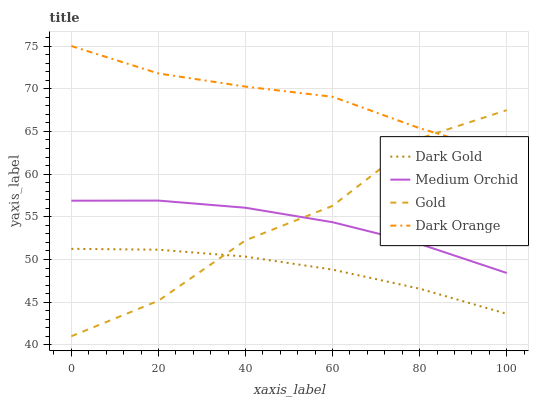Does Dark Gold have the minimum area under the curve?
Answer yes or no. Yes. Does Dark Orange have the maximum area under the curve?
Answer yes or no. Yes. Does Medium Orchid have the minimum area under the curve?
Answer yes or no. No. Does Medium Orchid have the maximum area under the curve?
Answer yes or no. No. Is Dark Gold the smoothest?
Answer yes or no. Yes. Is Gold the roughest?
Answer yes or no. Yes. Is Medium Orchid the smoothest?
Answer yes or no. No. Is Medium Orchid the roughest?
Answer yes or no. No. Does Gold have the lowest value?
Answer yes or no. Yes. Does Medium Orchid have the lowest value?
Answer yes or no. No. Does Dark Orange have the highest value?
Answer yes or no. Yes. Does Medium Orchid have the highest value?
Answer yes or no. No. Is Dark Gold less than Medium Orchid?
Answer yes or no. Yes. Is Dark Orange greater than Medium Orchid?
Answer yes or no. Yes. Does Gold intersect Medium Orchid?
Answer yes or no. Yes. Is Gold less than Medium Orchid?
Answer yes or no. No. Is Gold greater than Medium Orchid?
Answer yes or no. No. Does Dark Gold intersect Medium Orchid?
Answer yes or no. No. 